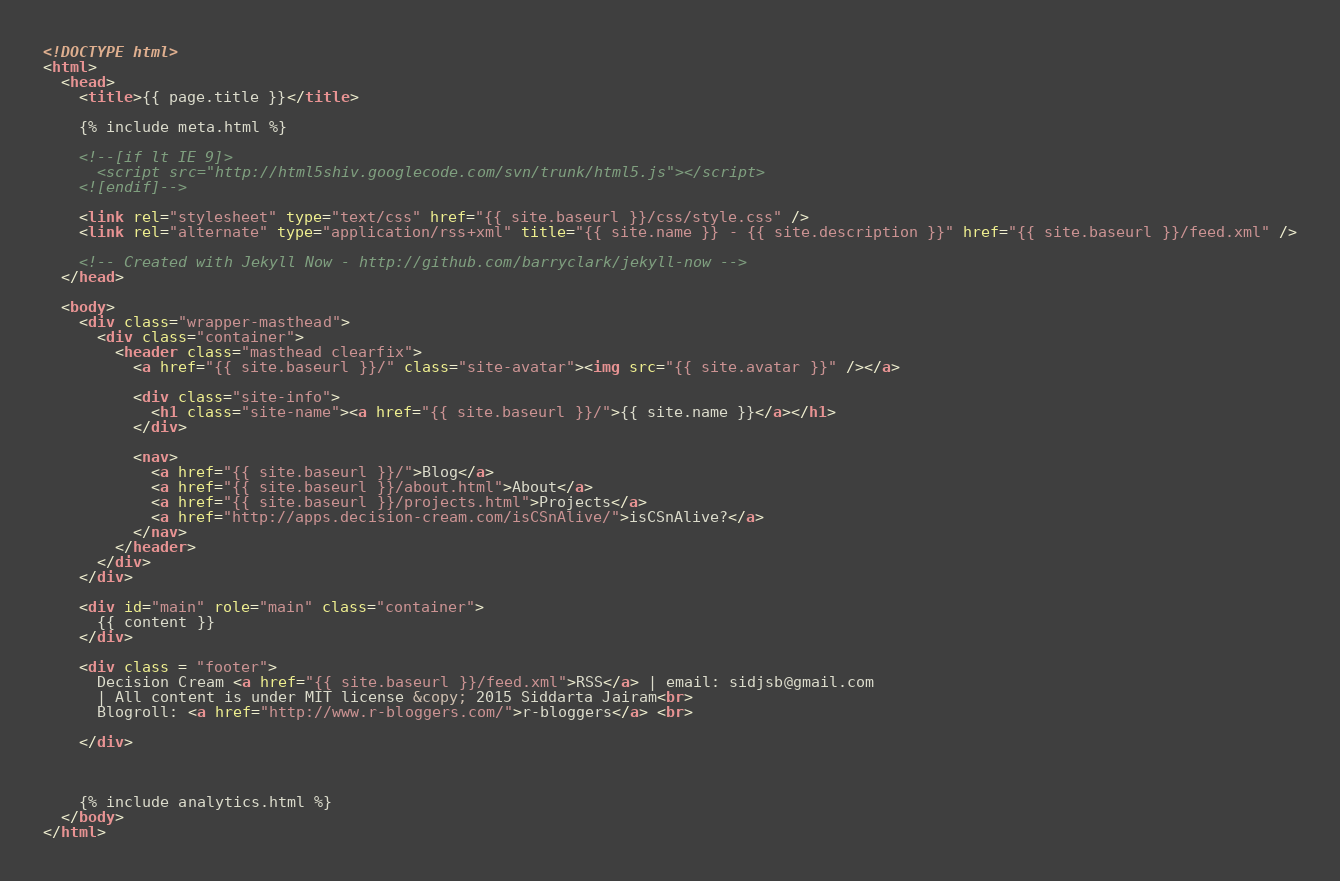Convert code to text. <code><loc_0><loc_0><loc_500><loc_500><_HTML_><!DOCTYPE html>
<html>
  <head>
    <title>{{ page.title }}</title>

    {% include meta.html %}

    <!--[if lt IE 9]>
      <script src="http://html5shiv.googlecode.com/svn/trunk/html5.js"></script>
    <![endif]-->

    <link rel="stylesheet" type="text/css" href="{{ site.baseurl }}/css/style.css" />
    <link rel="alternate" type="application/rss+xml" title="{{ site.name }} - {{ site.description }}" href="{{ site.baseurl }}/feed.xml" />

    <!-- Created with Jekyll Now - http://github.com/barryclark/jekyll-now -->
  </head>

  <body>
    <div class="wrapper-masthead">
      <div class="container">
        <header class="masthead clearfix">
          <a href="{{ site.baseurl }}/" class="site-avatar"><img src="{{ site.avatar }}" /></a>

          <div class="site-info">
            <h1 class="site-name"><a href="{{ site.baseurl }}/">{{ site.name }}</a></h1>
          </div>

          <nav>
            <a href="{{ site.baseurl }}/">Blog</a>
            <a href="{{ site.baseurl }}/about.html">About</a>
            <a href="{{ site.baseurl }}/projects.html">Projects</a>
            <a href="http://apps.decision-cream.com/isCSnAlive/">isCSnAlive?</a>
          </nav>
        </header>
      </div>
    </div>

    <div id="main" role="main" class="container">
      {{ content }}
    </div>

    <div class = "footer">
      Decision Cream <a href="{{ site.baseurl }}/feed.xml">RSS</a> | email: sidjsb@gmail.com
      | All content is under MIT license &copy; 2015 Siddarta Jairam<br>
      Blogroll: <a href="http://www.r-bloggers.com/">r-bloggers</a> <br>

    </div>



    {% include analytics.html %}
  </body>
</html>
</code> 